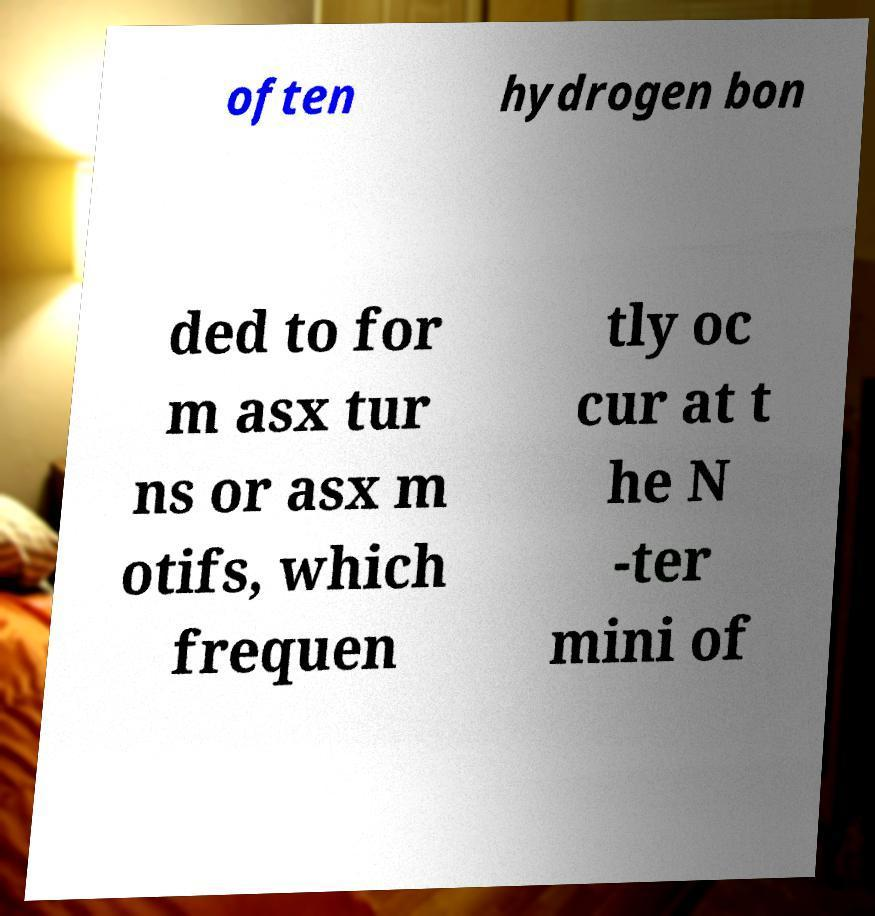Can you read and provide the text displayed in the image?This photo seems to have some interesting text. Can you extract and type it out for me? often hydrogen bon ded to for m asx tur ns or asx m otifs, which frequen tly oc cur at t he N -ter mini of 